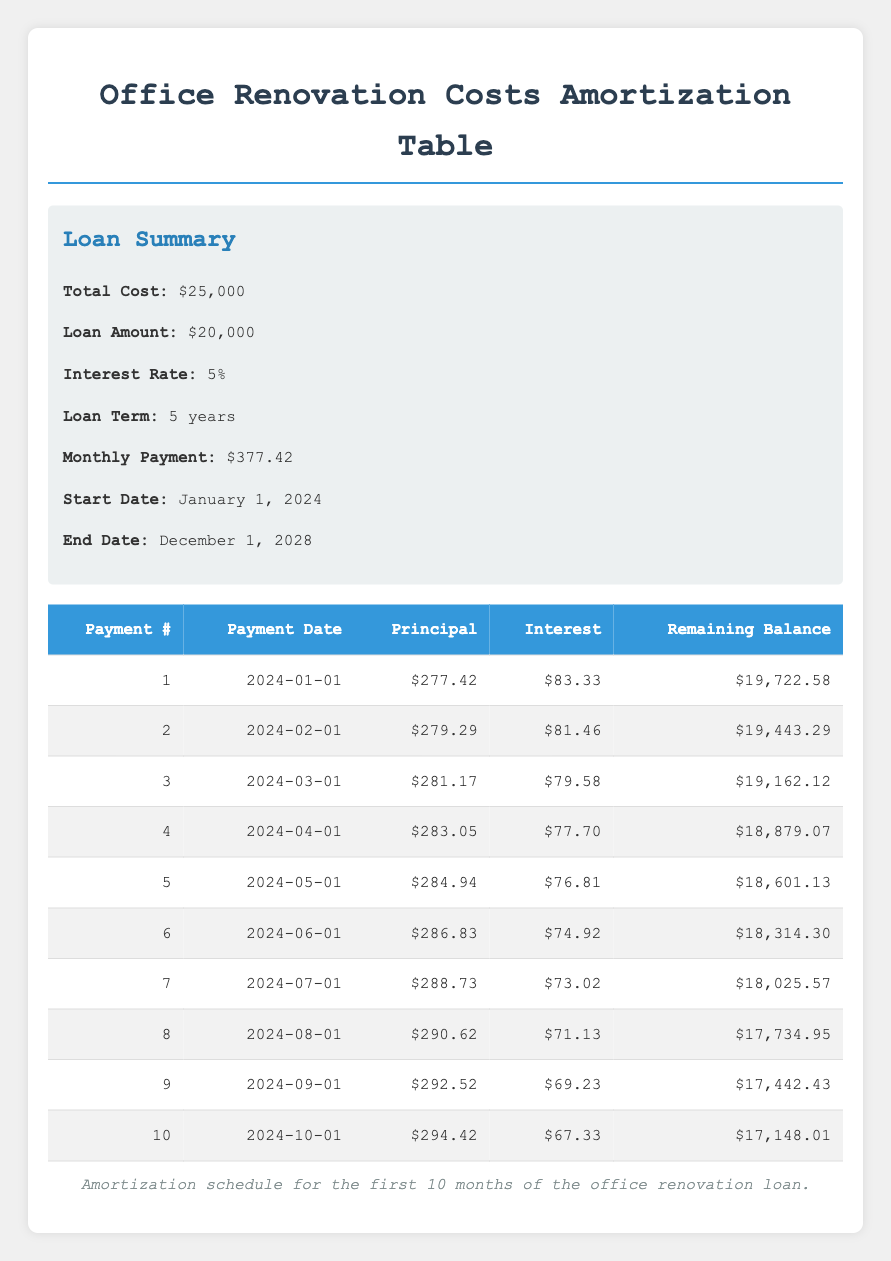What is the principal payment for the first month? The principal payment for the first month is listed in the first row of the amortization schedule as $277.42.
Answer: 277.42 What is the remaining balance after the third payment? To find the remaining balance after the third payment, we refer to the third row of the amortization schedule, which indicates that the remaining balance is $19,162.12.
Answer: 19162.12 Is the interest payment for the sixth month higher than $75? The interest payment for the sixth month is noted in the sixth row as $74.92. Since $74.92 is less than $75, the statement is false.
Answer: No What is the total principal paid in the first ten payments? To find the total principal paid, we sum the principal payments from the first ten rows: 277.42 + 279.29 + 281.17 + 283.05 + 284.94 + 286.83 + 288.73 + 290.62 + 292.52 + 294.42, which equals $2,788.98.
Answer: 2788.98 How much is the interest payment for the second month? The interest payment for the second month is provided in the second row of the amortization schedule as $81.46.
Answer: 81.46 What is the average principal payment over the first 10 payments? To calculate the average principal payment, we sum the principal payments of the first ten payments and divide by 10. The total is $2,788.98, so the average is $2,788.98 divided by 10, which is $278.90.
Answer: 278.90 Is the total cost of the office renovation $25,000? The total cost listed in the summary section states that the total cost of the office renovation is $25,000. Thus, this statement is true.
Answer: Yes What is the highest principal payment among the first ten months? By reviewing the principal payments in the first ten rows, we find the highest payment is in the fifth month at $284.94, as it is greater than any other month's principal payment.
Answer: 284.94 What will be the remaining balance after the tenth payment? The remaining balance after the tenth payment can be found in the tenth row of the amortization schedule, which shows a remaining balance of $17,148.01.
Answer: 17148.01 